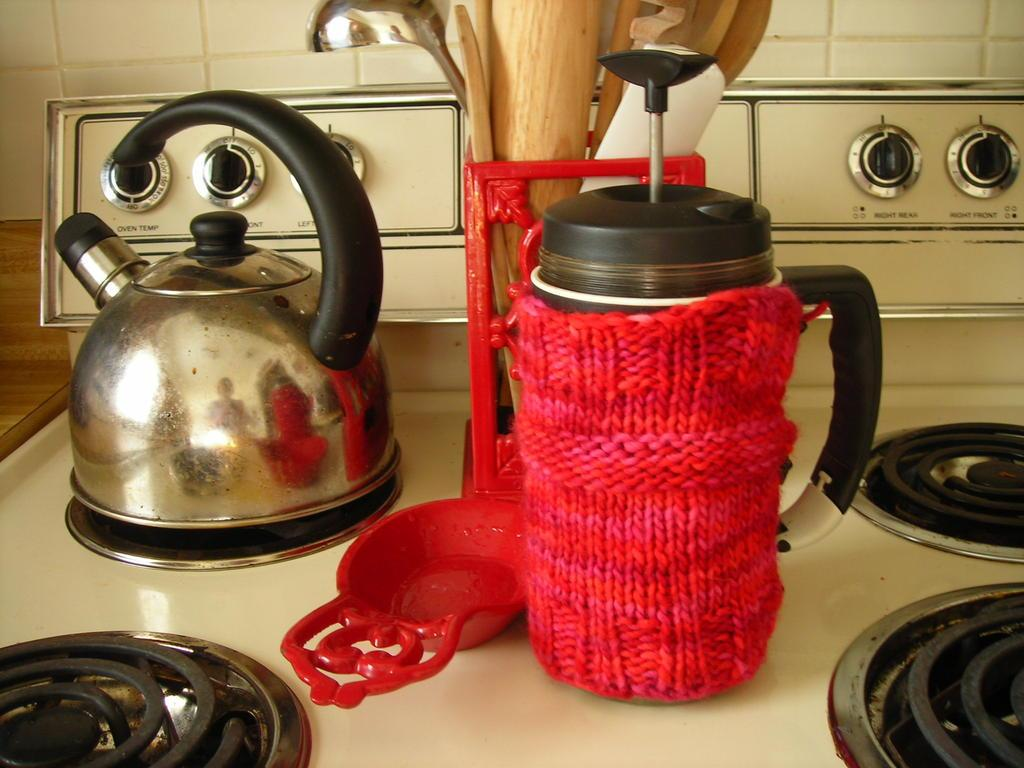<image>
Present a compact description of the photo's key features. the nob on the very left hand side is for oven temperature 